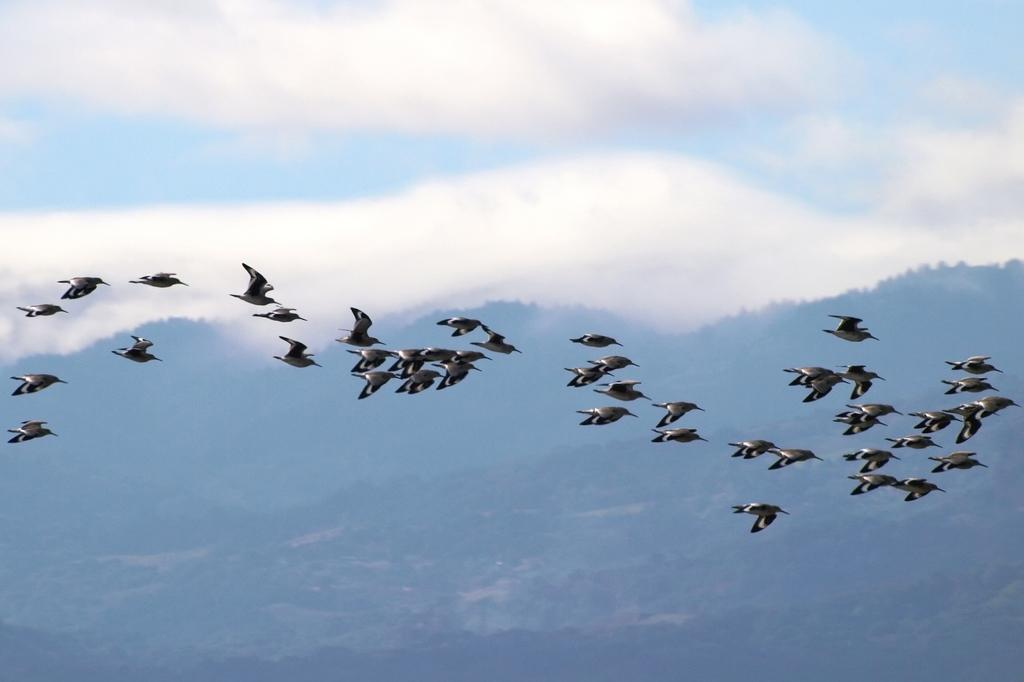What type of animals can be seen in the image? There are birds in the image. What type of natural landscape is visible in the image? There are hills visible in the image. What part of the natural environment is visible in the image? The sky is visible in the image. What can be seen in the sky in the image? Clouds are present in the sky. Reasoning: Let'ing: Let's think step by step in order to produce the conversation. We start by identifying the main subjects in the image, which are the image. Then, we expand the conversation to include other elements that are also visible, such as the hills and the sky. Each question is designed to elicit a specific detail about the image that is known from the provided facts. Absurd Question/Answer: What type of sweater is the bird wearing in the image? There is no sweater present on the birds in the image, as birds do not wear clothing. What type of air can be seen in the image? There is no specific type of air visible in the image; it is simply the sky and clouds. What type of insect is flying around the birds in the image? There is no insect present in the image; it only features birds, hills, and the sky. 